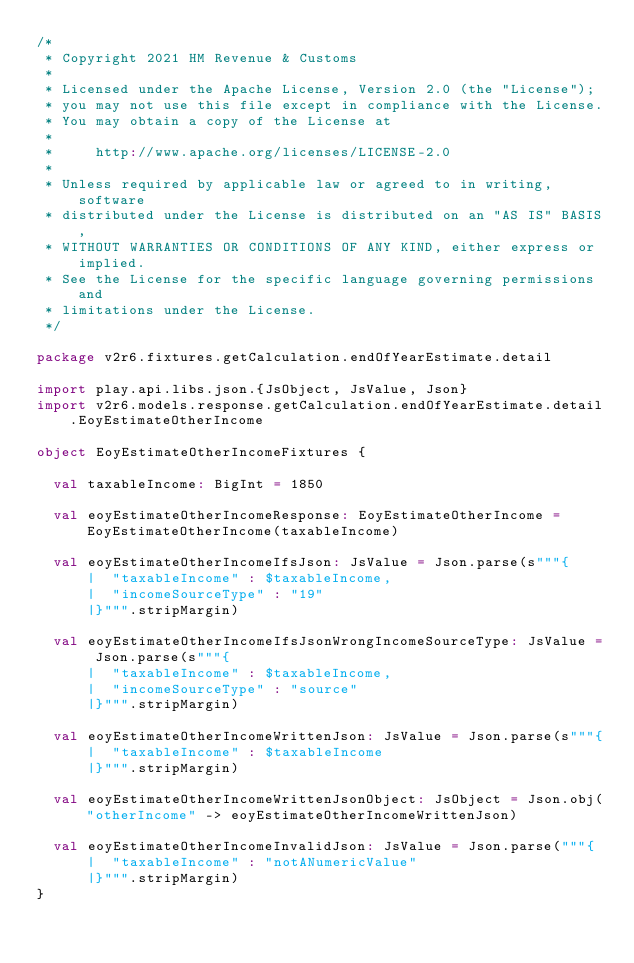<code> <loc_0><loc_0><loc_500><loc_500><_Scala_>/*
 * Copyright 2021 HM Revenue & Customs
 *
 * Licensed under the Apache License, Version 2.0 (the "License");
 * you may not use this file except in compliance with the License.
 * You may obtain a copy of the License at
 *
 *     http://www.apache.org/licenses/LICENSE-2.0
 *
 * Unless required by applicable law or agreed to in writing, software
 * distributed under the License is distributed on an "AS IS" BASIS,
 * WITHOUT WARRANTIES OR CONDITIONS OF ANY KIND, either express or implied.
 * See the License for the specific language governing permissions and
 * limitations under the License.
 */

package v2r6.fixtures.getCalculation.endOfYearEstimate.detail

import play.api.libs.json.{JsObject, JsValue, Json}
import v2r6.models.response.getCalculation.endOfYearEstimate.detail.EoyEstimateOtherIncome

object EoyEstimateOtherIncomeFixtures {

  val taxableIncome: BigInt = 1850

  val eoyEstimateOtherIncomeResponse: EoyEstimateOtherIncome = EoyEstimateOtherIncome(taxableIncome)

  val eoyEstimateOtherIncomeIfsJson: JsValue = Json.parse(s"""{
      |  "taxableIncome" : $taxableIncome,
      |  "incomeSourceType" : "19"
      |}""".stripMargin)

  val eoyEstimateOtherIncomeIfsJsonWrongIncomeSourceType: JsValue = Json.parse(s"""{
      |  "taxableIncome" : $taxableIncome,
      |  "incomeSourceType" : "source"
      |}""".stripMargin)

  val eoyEstimateOtherIncomeWrittenJson: JsValue = Json.parse(s"""{
      |  "taxableIncome" : $taxableIncome
      |}""".stripMargin)

  val eoyEstimateOtherIncomeWrittenJsonObject: JsObject = Json.obj("otherIncome" -> eoyEstimateOtherIncomeWrittenJson)

  val eoyEstimateOtherIncomeInvalidJson: JsValue = Json.parse("""{
      |  "taxableIncome" : "notANumericValue"
      |}""".stripMargin)
}</code> 